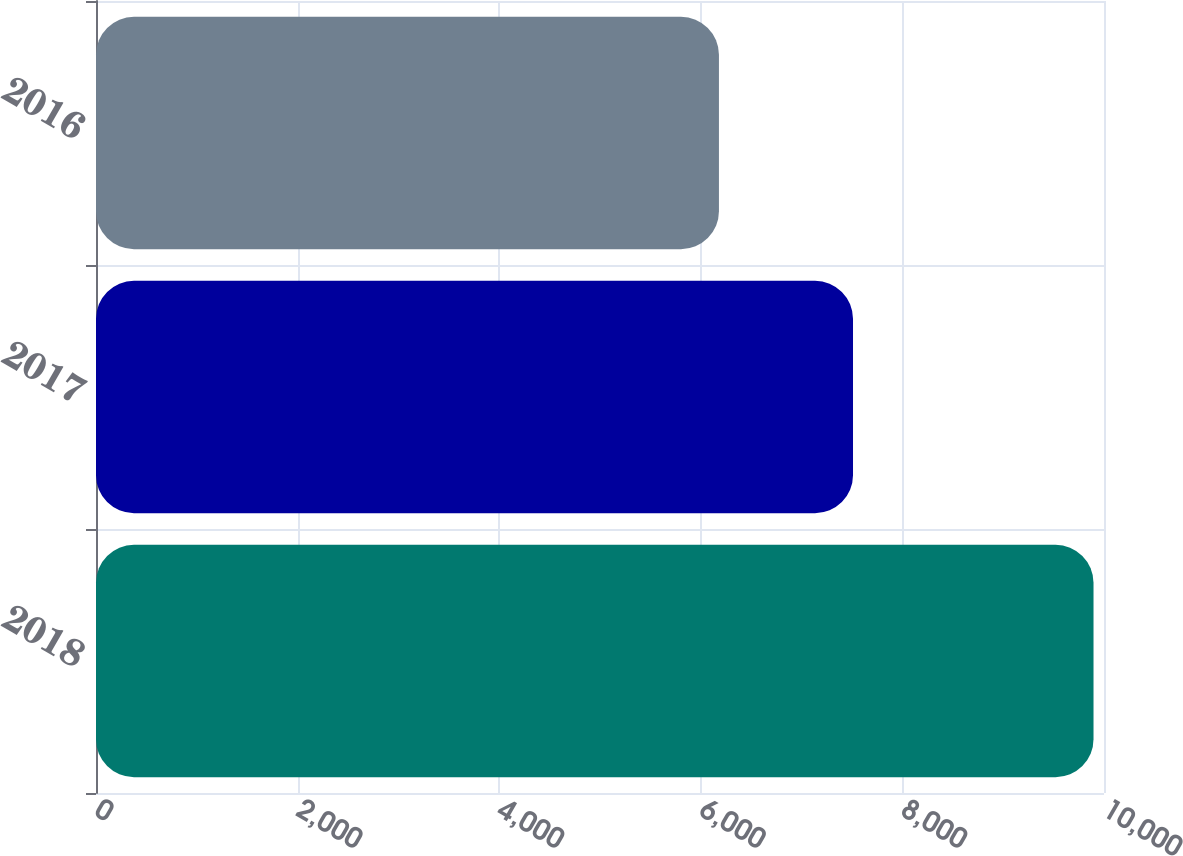Convert chart to OTSL. <chart><loc_0><loc_0><loc_500><loc_500><bar_chart><fcel>2018<fcel>2017<fcel>2016<nl><fcel>9896<fcel>7510<fcel>6180<nl></chart> 